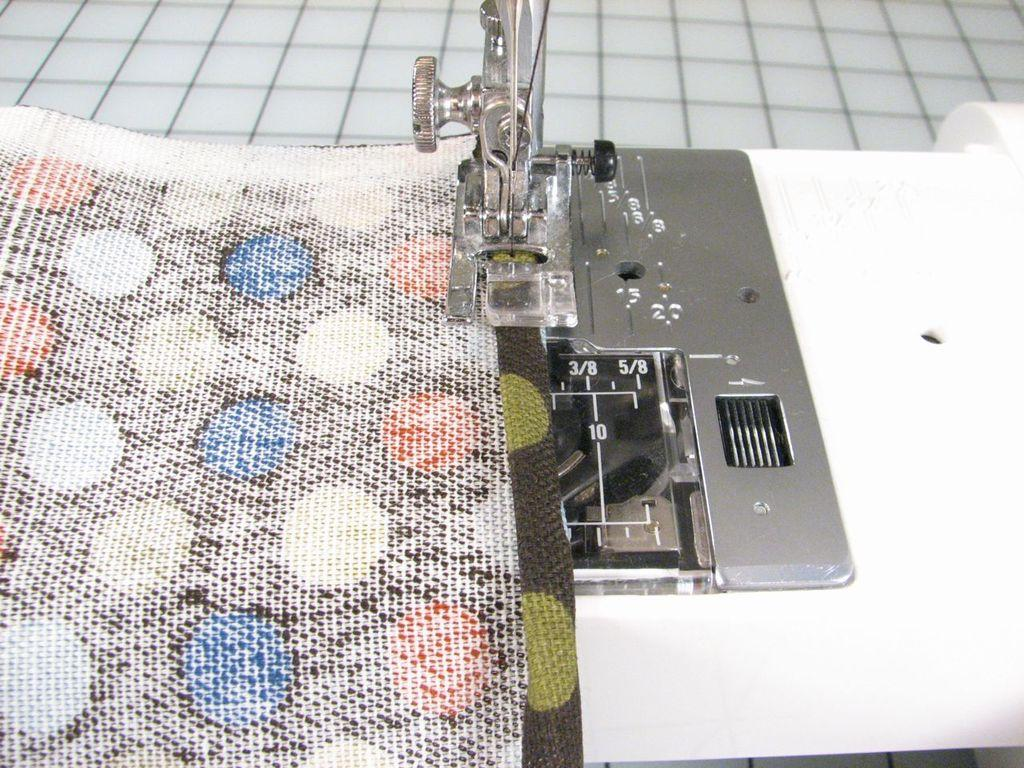What is on the sewing machine in the image? There is a cloth on the sewing machine in the image. What can be seen in the background of the image? The background of the image includes the floor. What type of flower is growing on the sewing machine in the image? There are no flowers present on the sewing machine in the image. 